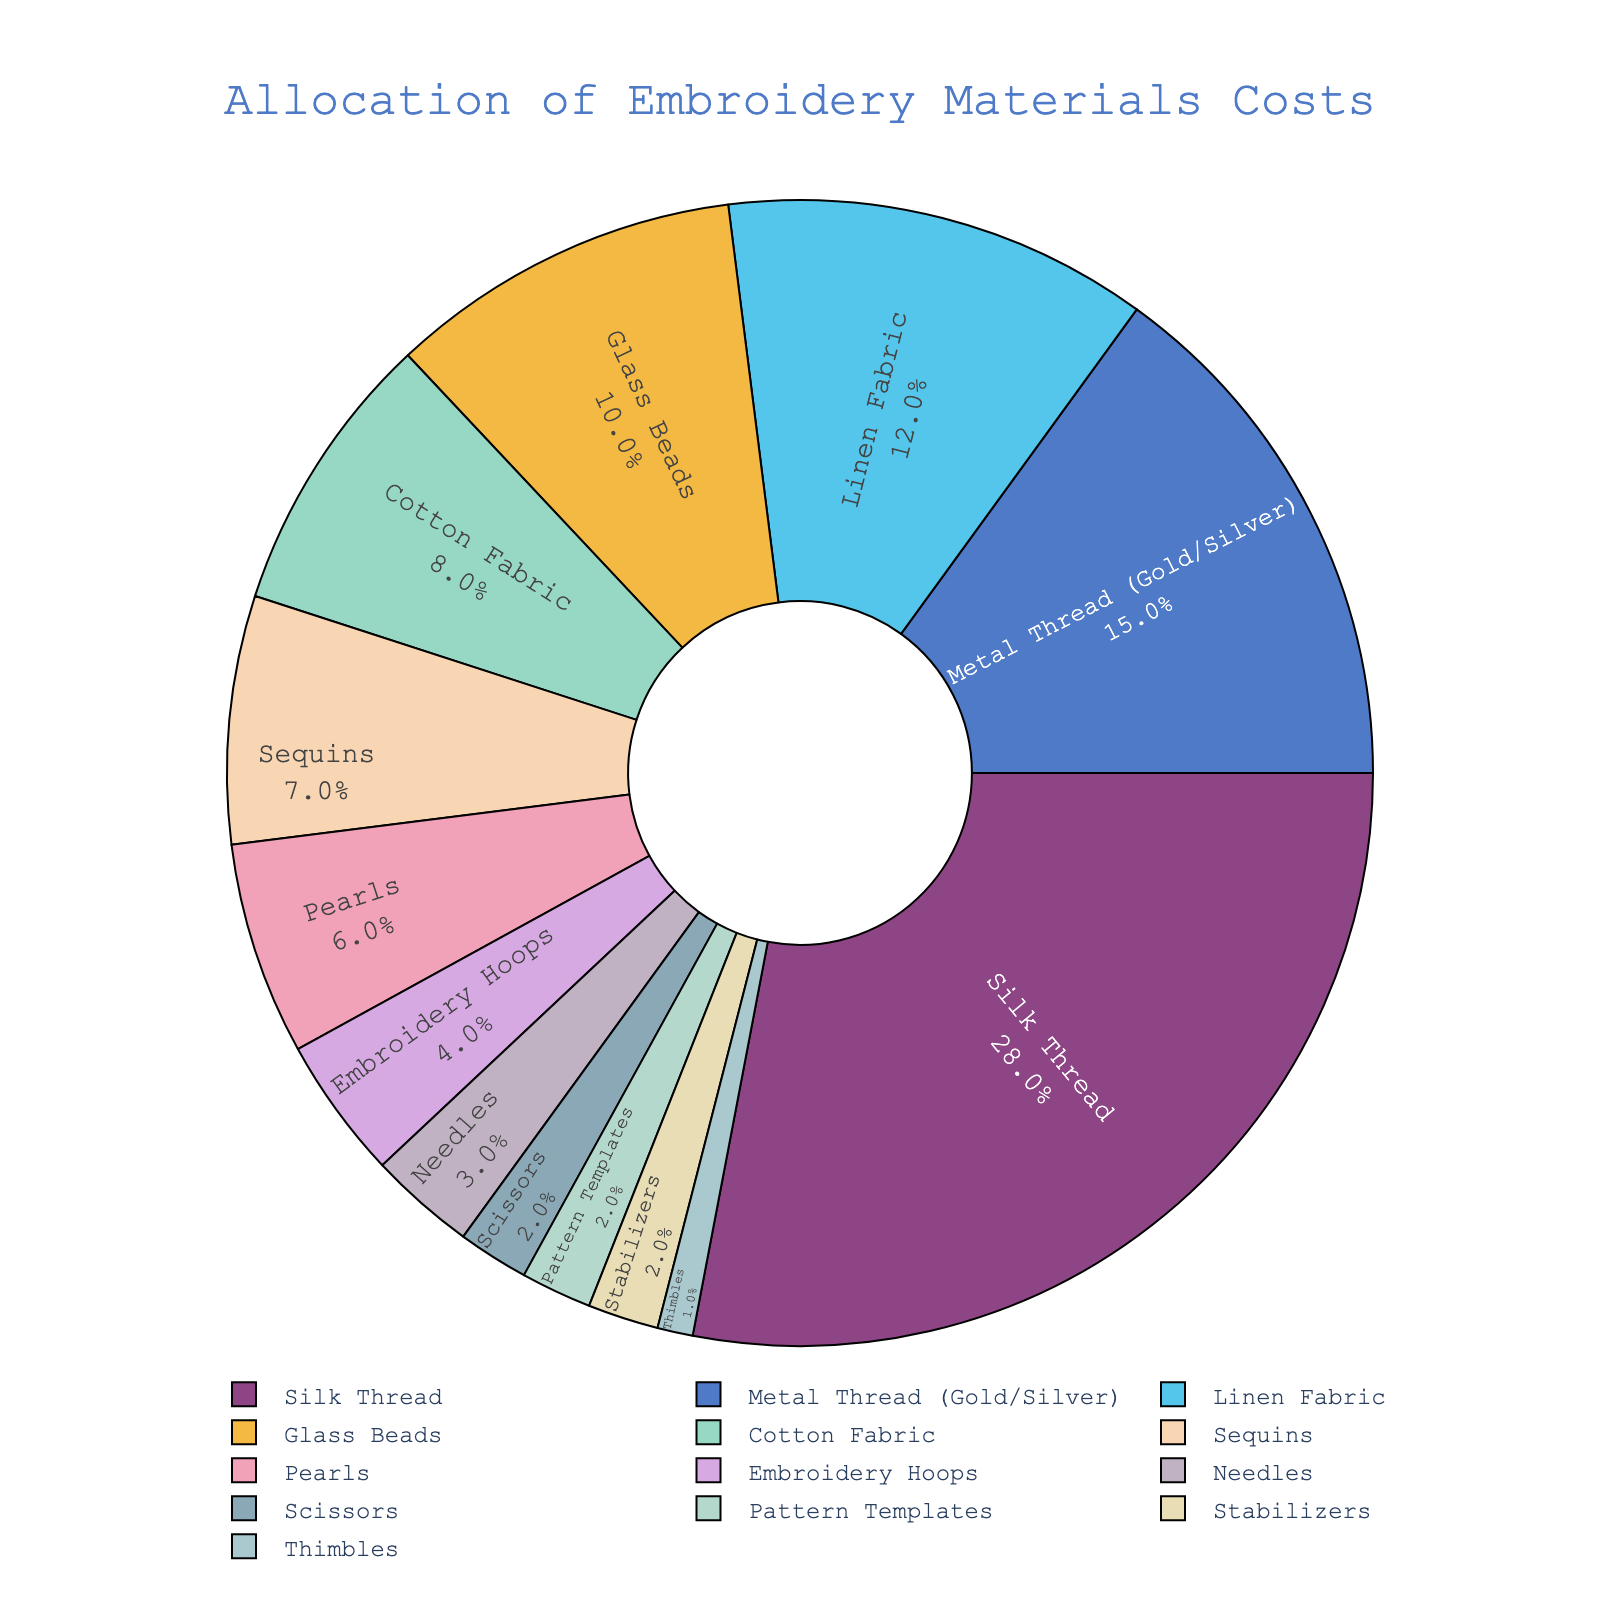What material holds the highest cost percentage? To find the material with the highest cost percentage, look for the largest slice of the pie chart. This slice represents the highest value.
Answer: Silk Thread Which is more expensive in terms of allocation, Glass Beads or Cotton Fabric? To compare Glass Beads with Cotton Fabric, check their respective sizes on the pie chart. Glass Beads have a larger slice than Cotton Fabric.
Answer: Glass Beads If you sum the cost percentages of Scissors and Thimbles, what do you get? Identify the cost percentages for Scissors and Thimbles from the pie chart (2% and 1%, respectively). Summing them gives 2% + 1% = 3%.
Answer: 3% Between Linen Fabric and Metal Thread (Gold/Silver), which has a greater cost percentage and by how much? Compare the slices for Linen Fabric and Metal Thread. Linen Fabric is 12%, and Metal Thread is 15%. The difference is 15% - 12% = 3%.
Answer: Metal Thread by 3% Rank Silk Thread, Pearls, and Sequins from highest to lowest cost percentage. Examine the slices for Silk Thread (28%), Pearls (6%), and Sequins (7%). The order from highest to lowest is: Silk Thread > Sequins > Pearls.
Answer: Silk Thread, Sequins, Pearls How much greater is the cost percentage of Embroidery Hoops compared to Pattern Templates? Locate the percentages for Embroidery Hoops (4%) and Pattern Templates (2%). The difference is 4% - 2% = 2%.
Answer: 2% Are the combined costs of Stabilizers and Needles greater than the cost of Glass Beads? Check the percentages for Stabilizers (2%) and Needles (3%). Their combined cost is 2% + 3% = 5%. Compare this to Glass Beads (10%). 5% is less than 10%.
Answer: No What percentage of the total cost is attributed to Scissors, Thimbles, and Pattern Templates combined? Sum the percentages for Scissors (2%), Thimbles (1%), and Pattern Templates (2%). The total is 2% + 1% + 2% = 5%.
Answer: 5% Which materials collectively make up one-third of the total cost? To find one-third of the total cost (100%), calculate 100% / 3 = 33.33%. The sum of the percentages of Silk Thread (28%) and Metal Thread (15%) is 28% + 15% = 43%, which is slightly over one-third. Therefore, look for combinations totaling near 33%. Silk Thread (28%) and Linen Fabric (12%) gives 28% + 12% = 40%, so a closer answer might involve other combinations. The exact visually closest combination could be Silk Thread (28%), and one smaller material such as Glass Beads (10%) adding together to 38%. Adjust as visually closer.
Answer: Silk Thread (28%) + Metal Thread (15%) (43%) What are the combined cost percentages of all materials used in decoration (Glass Beads, Sequins, Pearls)? Add the percentages for Glass Beads (10%), Sequins (7%), and Pearls (6%). The total is 10% + 7% + 6% = 23%.
Answer: 23% 